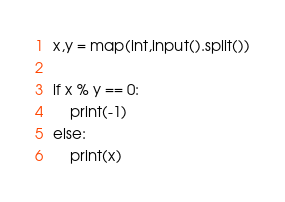Convert code to text. <code><loc_0><loc_0><loc_500><loc_500><_Python_>x,y = map(int,input().split())

if x % y == 0:
    print(-1)
else:
    print(x)</code> 